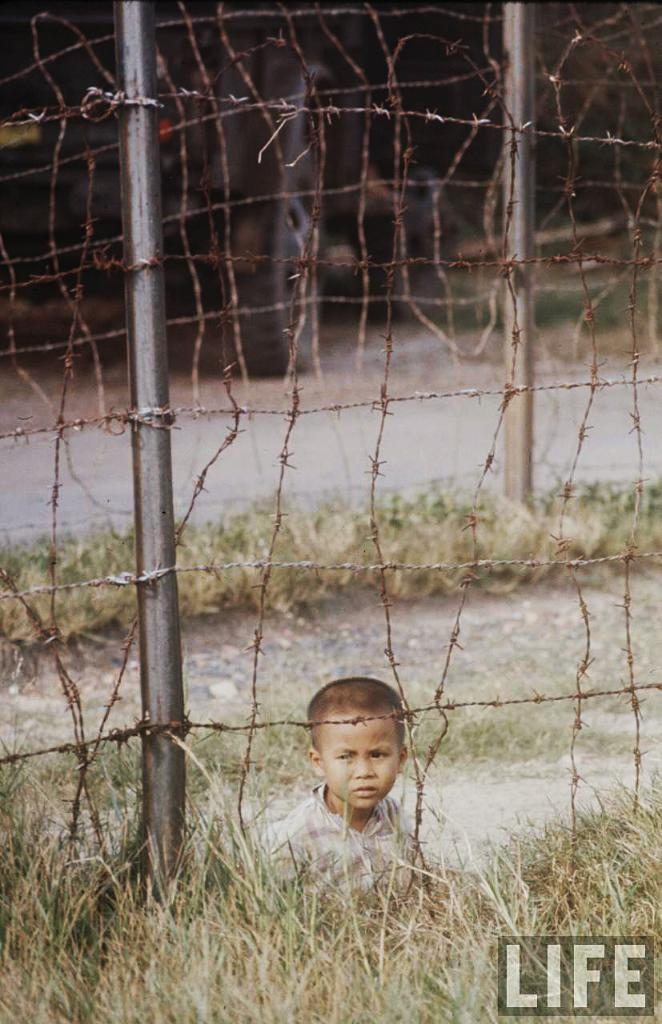What type of vegetation is present in the image? There is grass in the image. What can be seen surrounding the grass? There is fencing in the image. Is there a person visible in the image? Yes, a boy is visible behind the fencing. Can you describe any additional features of the image? There is a watermark in the right bottom corner of the image. What type of bean is being sliced by the blade in the image? There is no bean or blade present in the image. What sound can be heard coming from the boy in the image? The image is silent, so no sound can be heard. 